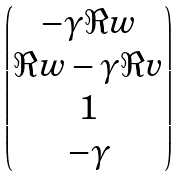Convert formula to latex. <formula><loc_0><loc_0><loc_500><loc_500>\begin{pmatrix} - \gamma \Re { w } \\ \Re { w } - \gamma \Re { v } \\ 1 \\ - \gamma \end{pmatrix}</formula> 